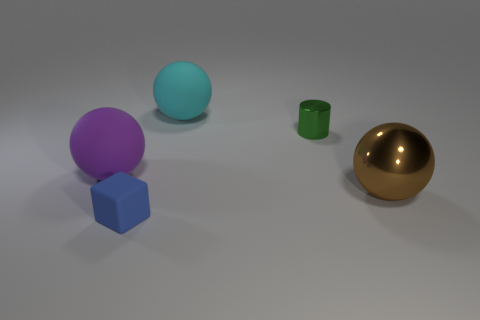Subtract all matte balls. How many balls are left? 1 Subtract all brown balls. How many balls are left? 2 Add 4 tiny blue shiny cylinders. How many objects exist? 9 Subtract 1 cyan balls. How many objects are left? 4 Subtract all cylinders. How many objects are left? 4 Subtract 2 spheres. How many spheres are left? 1 Subtract all gray spheres. Subtract all cyan cylinders. How many spheres are left? 3 Subtract all tiny objects. Subtract all matte objects. How many objects are left? 0 Add 5 big brown things. How many big brown things are left? 6 Add 2 balls. How many balls exist? 5 